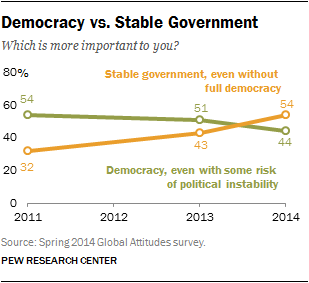Outline some significant characteristics in this image. The ratio of people in favor of democracy and stable government in the year 2011 was 1.6875. In 2013, there were individuals who supported democracy despite the potential for political instability. 